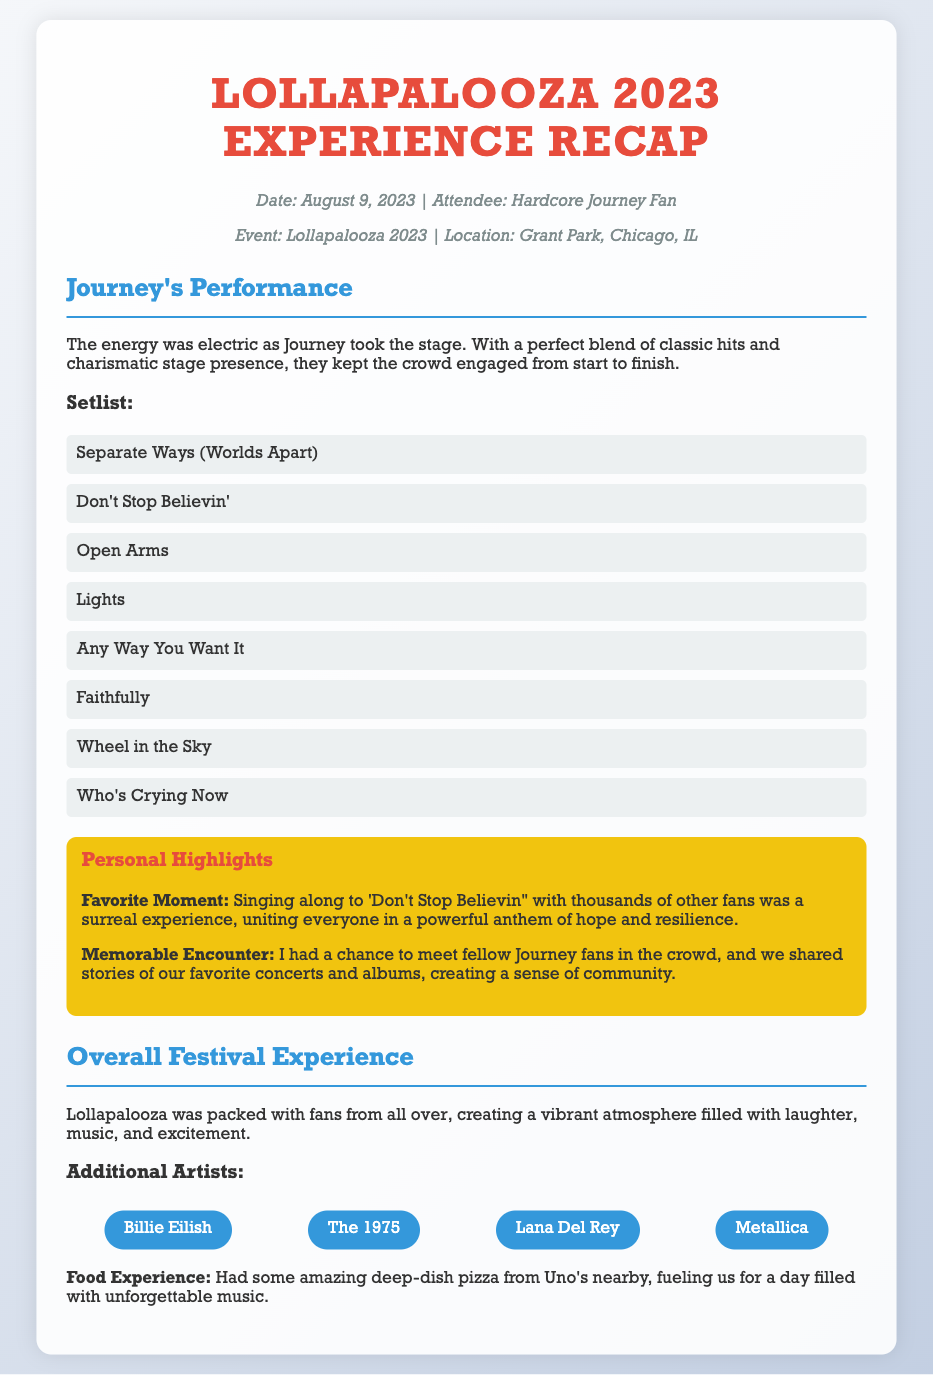what was the date of Lollapalooza 2023? The date of Lollapalooza 2023 is mentioned in the meta section of the document.
Answer: August 9, 2023 where was Lollapalooza 2023 held? The location of the event is stated in the meta section.
Answer: Grant Park, Chicago, IL which band performed at Lollapalooza 2023? The performance details specifically highlight that Journey took the stage.
Answer: Journey what is the first song on Journey's setlist? The setlist is listed in the document, and the first song is noted at the top of the list.
Answer: Separate Ways (Worlds Apart) what was the favorite moment mentioned in the highlights? The document notes a specific moment as the favorite highlight related to a song.
Answer: Singing along to 'Don't Stop Believin'' how many songs are listed in Journey's setlist? The setlist is presented as a list of songs; counting them provides the answer.
Answer: 8 who was the attendee of the event? The document specifies the attendee in the meta section.
Answer: Hardcore Journey Fan which food experience is mentioned? The document describes a specific food experience during the festival.
Answer: Deep-dish pizza from Uno's 